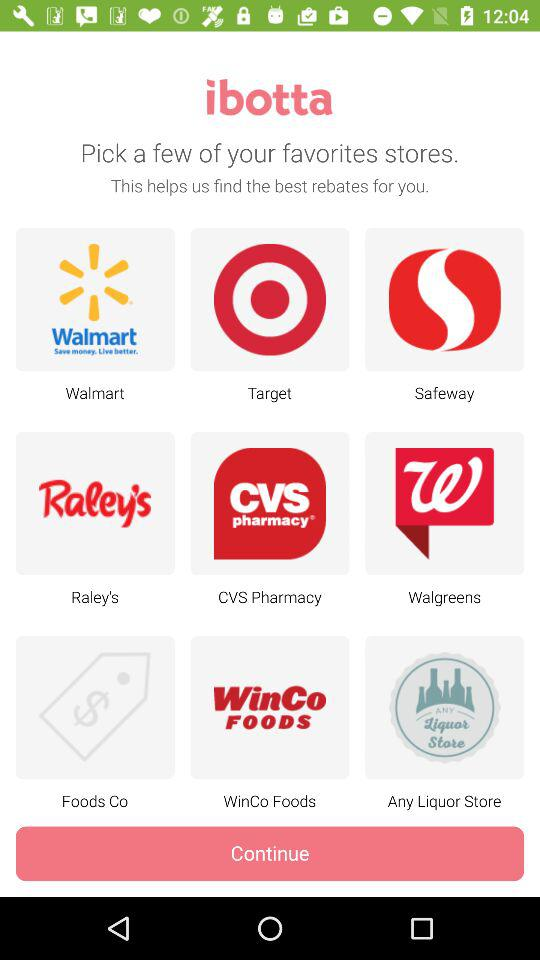Which are the favorite stores to choose? The favourite stores to choose from are "Walmart", "Target", "Safeway", "Raley's", "CVS Pharmacy", "Walgreens", "Foods Co", "WinCo Foods" and "Any Liquor Store". 